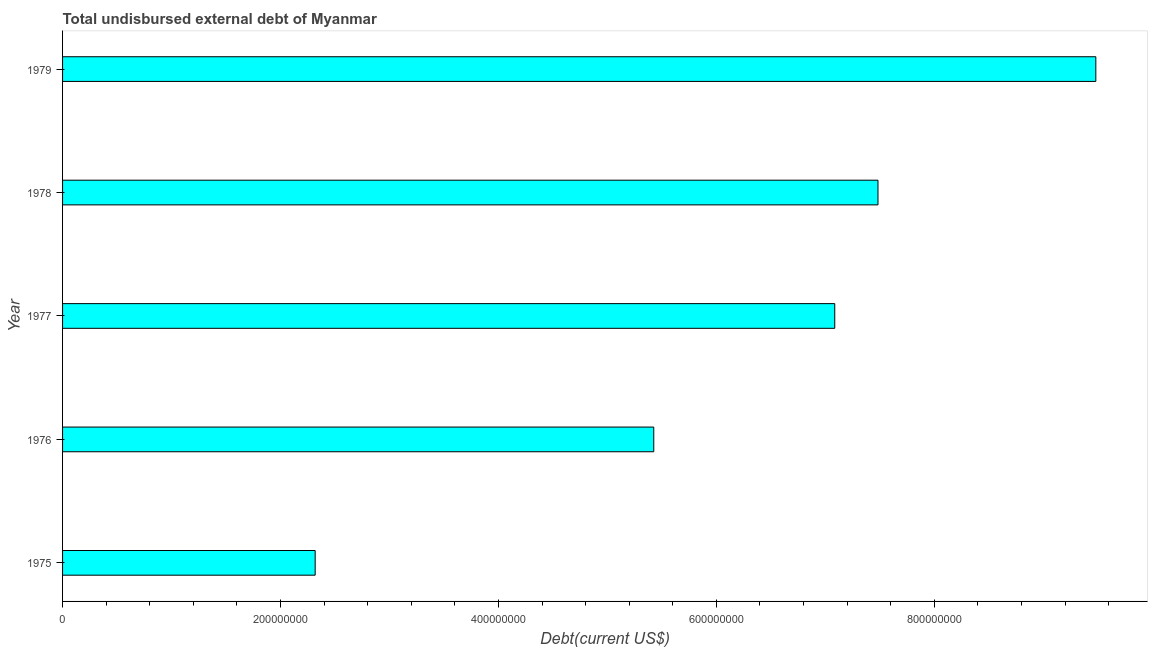What is the title of the graph?
Your answer should be very brief. Total undisbursed external debt of Myanmar. What is the label or title of the X-axis?
Keep it short and to the point. Debt(current US$). What is the label or title of the Y-axis?
Provide a short and direct response. Year. What is the total debt in 1979?
Your answer should be very brief. 9.48e+08. Across all years, what is the maximum total debt?
Keep it short and to the point. 9.48e+08. Across all years, what is the minimum total debt?
Make the answer very short. 2.32e+08. In which year was the total debt maximum?
Your response must be concise. 1979. In which year was the total debt minimum?
Provide a short and direct response. 1975. What is the sum of the total debt?
Keep it short and to the point. 3.18e+09. What is the difference between the total debt in 1977 and 1979?
Offer a very short reply. -2.40e+08. What is the average total debt per year?
Provide a succinct answer. 6.36e+08. What is the median total debt?
Offer a terse response. 7.09e+08. What is the ratio of the total debt in 1977 to that in 1979?
Your response must be concise. 0.75. Is the total debt in 1975 less than that in 1978?
Your response must be concise. Yes. Is the difference between the total debt in 1975 and 1978 greater than the difference between any two years?
Your answer should be very brief. No. What is the difference between the highest and the second highest total debt?
Offer a very short reply. 2.00e+08. Is the sum of the total debt in 1977 and 1978 greater than the maximum total debt across all years?
Your answer should be very brief. Yes. What is the difference between the highest and the lowest total debt?
Provide a short and direct response. 7.16e+08. How many bars are there?
Provide a short and direct response. 5. Are all the bars in the graph horizontal?
Make the answer very short. Yes. How many years are there in the graph?
Your response must be concise. 5. Are the values on the major ticks of X-axis written in scientific E-notation?
Keep it short and to the point. No. What is the Debt(current US$) in 1975?
Offer a terse response. 2.32e+08. What is the Debt(current US$) of 1976?
Provide a succinct answer. 5.43e+08. What is the Debt(current US$) of 1977?
Your response must be concise. 7.09e+08. What is the Debt(current US$) of 1978?
Provide a succinct answer. 7.48e+08. What is the Debt(current US$) of 1979?
Give a very brief answer. 9.48e+08. What is the difference between the Debt(current US$) in 1975 and 1976?
Keep it short and to the point. -3.11e+08. What is the difference between the Debt(current US$) in 1975 and 1977?
Offer a terse response. -4.77e+08. What is the difference between the Debt(current US$) in 1975 and 1978?
Provide a short and direct response. -5.16e+08. What is the difference between the Debt(current US$) in 1975 and 1979?
Offer a very short reply. -7.16e+08. What is the difference between the Debt(current US$) in 1976 and 1977?
Ensure brevity in your answer.  -1.66e+08. What is the difference between the Debt(current US$) in 1976 and 1978?
Your response must be concise. -2.06e+08. What is the difference between the Debt(current US$) in 1976 and 1979?
Ensure brevity in your answer.  -4.06e+08. What is the difference between the Debt(current US$) in 1977 and 1978?
Keep it short and to the point. -3.97e+07. What is the difference between the Debt(current US$) in 1977 and 1979?
Your response must be concise. -2.40e+08. What is the difference between the Debt(current US$) in 1978 and 1979?
Offer a very short reply. -2.00e+08. What is the ratio of the Debt(current US$) in 1975 to that in 1976?
Provide a succinct answer. 0.43. What is the ratio of the Debt(current US$) in 1975 to that in 1977?
Ensure brevity in your answer.  0.33. What is the ratio of the Debt(current US$) in 1975 to that in 1978?
Ensure brevity in your answer.  0.31. What is the ratio of the Debt(current US$) in 1975 to that in 1979?
Your answer should be very brief. 0.24. What is the ratio of the Debt(current US$) in 1976 to that in 1977?
Keep it short and to the point. 0.77. What is the ratio of the Debt(current US$) in 1976 to that in 1978?
Provide a short and direct response. 0.72. What is the ratio of the Debt(current US$) in 1976 to that in 1979?
Keep it short and to the point. 0.57. What is the ratio of the Debt(current US$) in 1977 to that in 1978?
Provide a short and direct response. 0.95. What is the ratio of the Debt(current US$) in 1977 to that in 1979?
Provide a short and direct response. 0.75. What is the ratio of the Debt(current US$) in 1978 to that in 1979?
Offer a terse response. 0.79. 